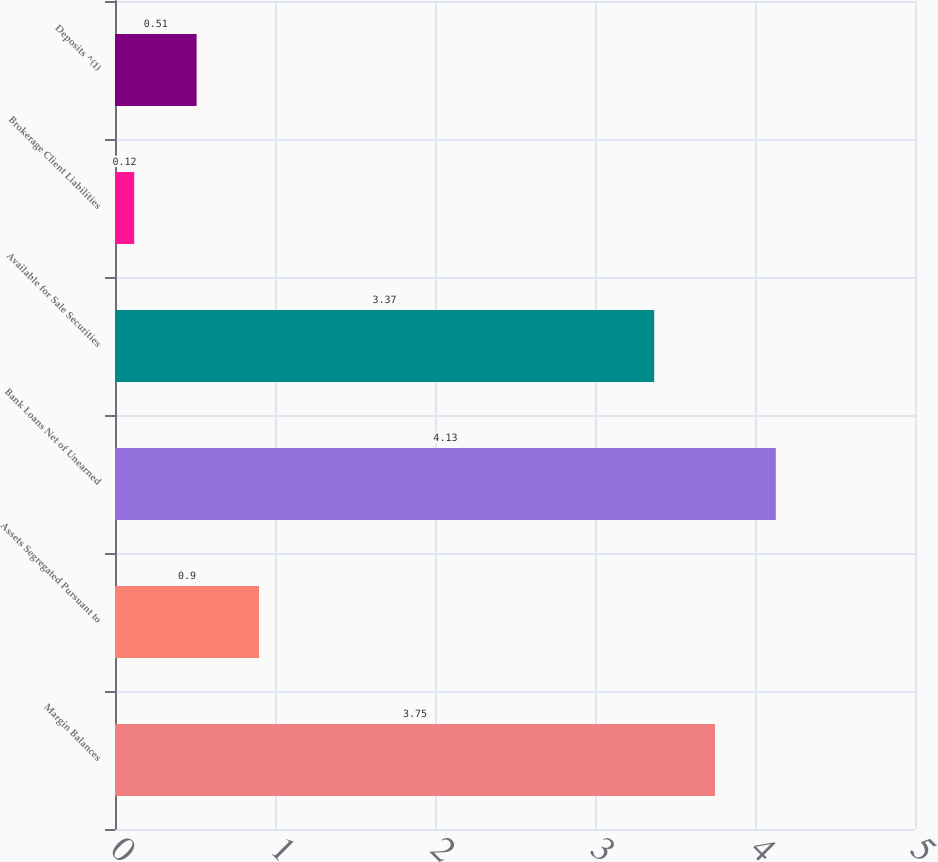<chart> <loc_0><loc_0><loc_500><loc_500><bar_chart><fcel>Margin Balances<fcel>Assets Segregated Pursuant to<fcel>Bank Loans Net of Unearned<fcel>Available for Sale Securities<fcel>Brokerage Client Liabilities<fcel>Deposits ^(1)<nl><fcel>3.75<fcel>0.9<fcel>4.13<fcel>3.37<fcel>0.12<fcel>0.51<nl></chart> 